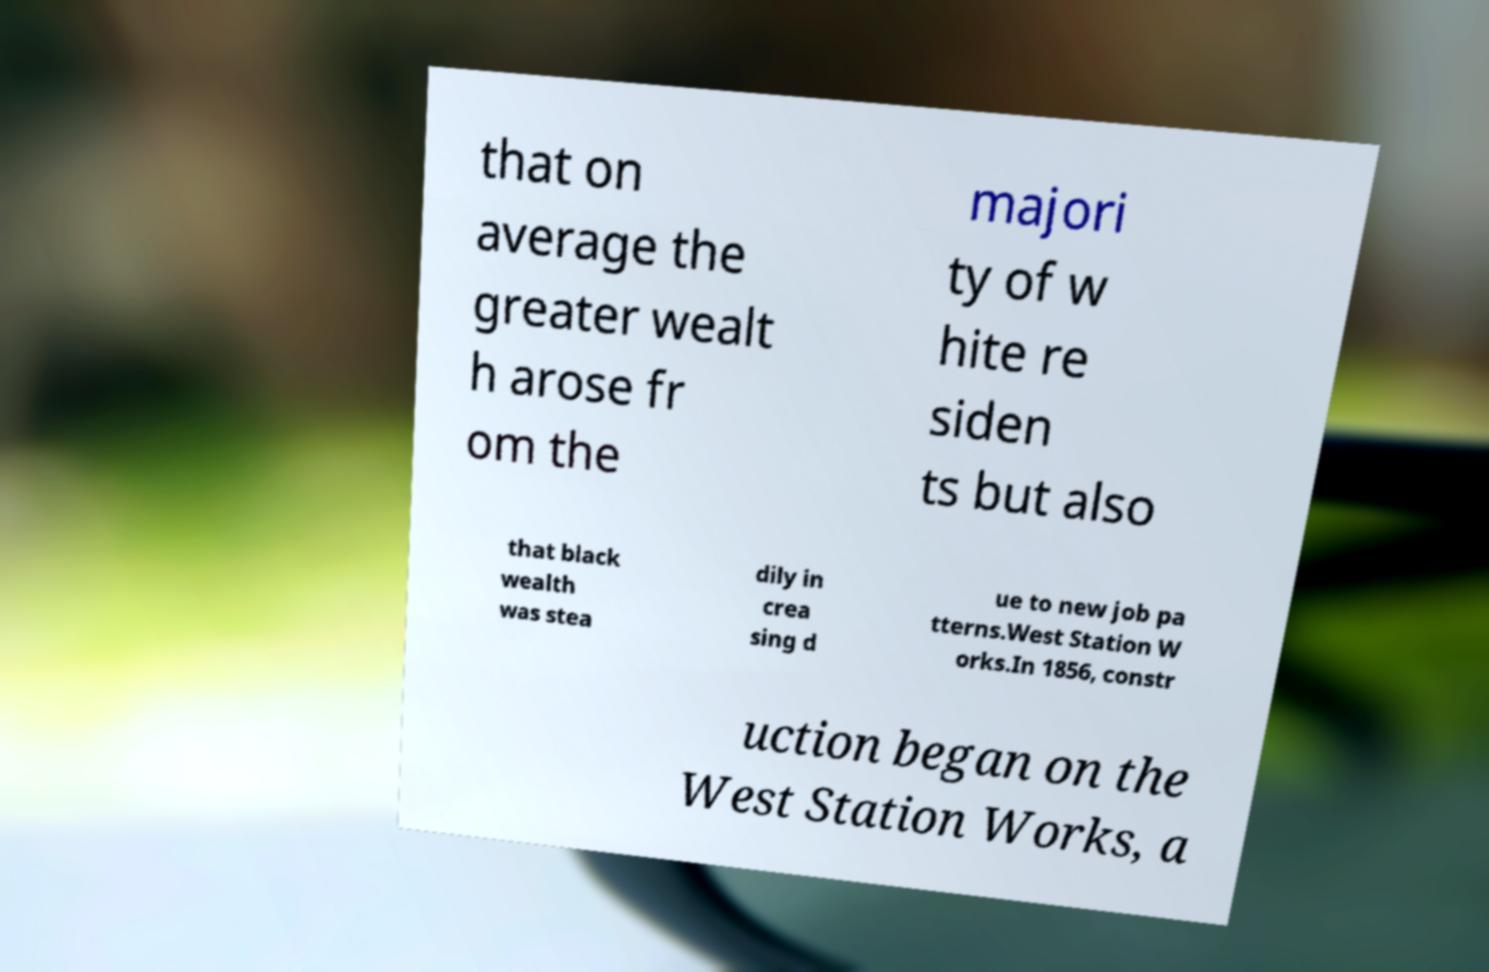For documentation purposes, I need the text within this image transcribed. Could you provide that? that on average the greater wealt h arose fr om the majori ty of w hite re siden ts but also that black wealth was stea dily in crea sing d ue to new job pa tterns.West Station W orks.In 1856, constr uction began on the West Station Works, a 